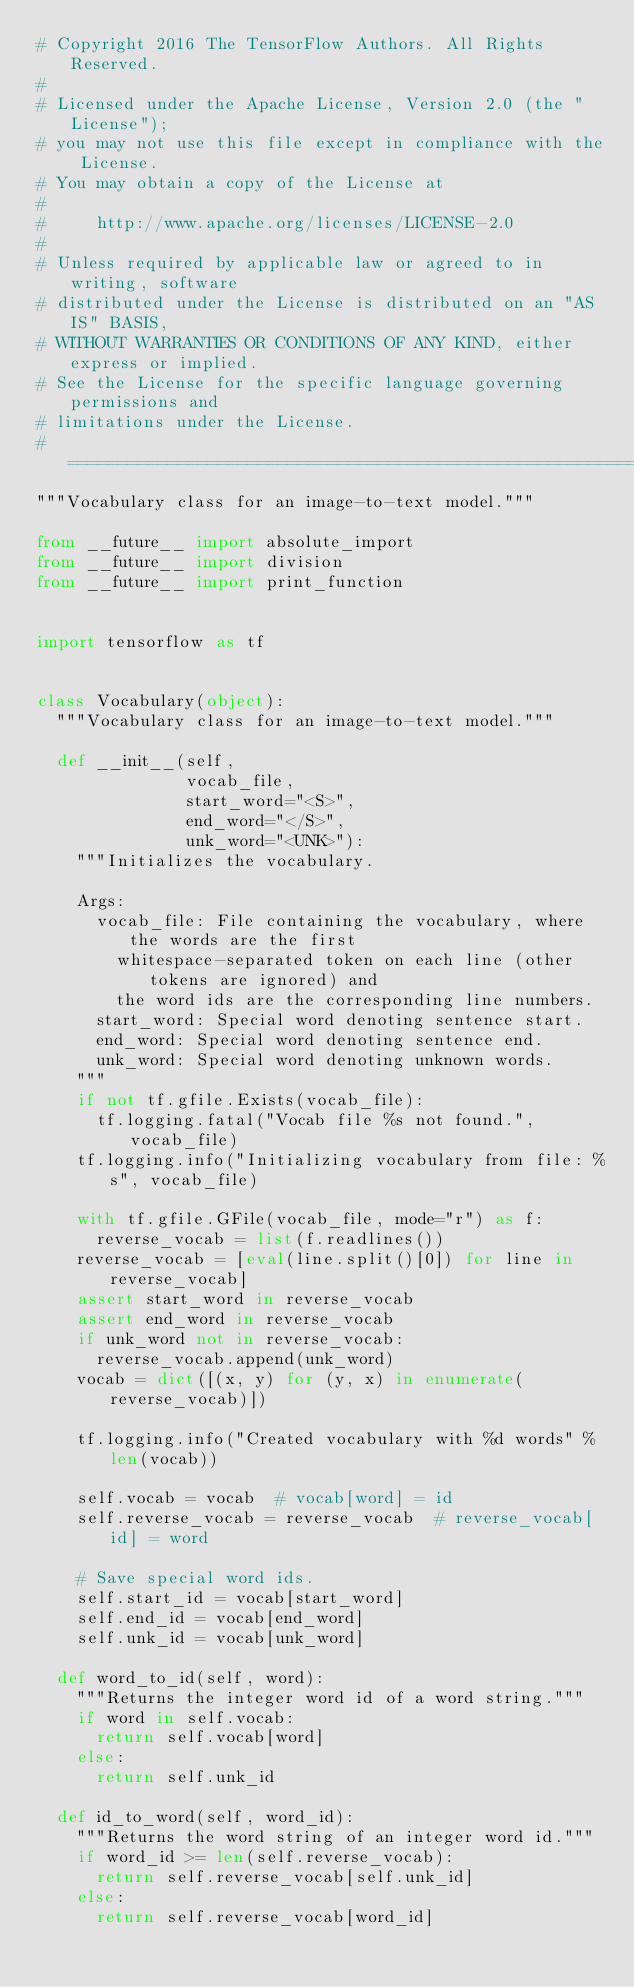<code> <loc_0><loc_0><loc_500><loc_500><_Python_># Copyright 2016 The TensorFlow Authors. All Rights Reserved.
#
# Licensed under the Apache License, Version 2.0 (the "License");
# you may not use this file except in compliance with the License.
# You may obtain a copy of the License at
#
#     http://www.apache.org/licenses/LICENSE-2.0
#
# Unless required by applicable law or agreed to in writing, software
# distributed under the License is distributed on an "AS IS" BASIS,
# WITHOUT WARRANTIES OR CONDITIONS OF ANY KIND, either express or implied.
# See the License for the specific language governing permissions and
# limitations under the License.
# ==============================================================================
"""Vocabulary class for an image-to-text model."""

from __future__ import absolute_import
from __future__ import division
from __future__ import print_function


import tensorflow as tf


class Vocabulary(object):
  """Vocabulary class for an image-to-text model."""

  def __init__(self,
               vocab_file,
               start_word="<S>",
               end_word="</S>",
               unk_word="<UNK>"):
    """Initializes the vocabulary.

    Args:
      vocab_file: File containing the vocabulary, where the words are the first
        whitespace-separated token on each line (other tokens are ignored) and
        the word ids are the corresponding line numbers.
      start_word: Special word denoting sentence start.
      end_word: Special word denoting sentence end.
      unk_word: Special word denoting unknown words.
    """
    if not tf.gfile.Exists(vocab_file):
      tf.logging.fatal("Vocab file %s not found.", vocab_file)
    tf.logging.info("Initializing vocabulary from file: %s", vocab_file)

    with tf.gfile.GFile(vocab_file, mode="r") as f:
      reverse_vocab = list(f.readlines())
    reverse_vocab = [eval(line.split()[0]) for line in reverse_vocab]
    assert start_word in reverse_vocab
    assert end_word in reverse_vocab
    if unk_word not in reverse_vocab:
      reverse_vocab.append(unk_word)
    vocab = dict([(x, y) for (y, x) in enumerate(reverse_vocab)])

    tf.logging.info("Created vocabulary with %d words" % len(vocab))

    self.vocab = vocab  # vocab[word] = id
    self.reverse_vocab = reverse_vocab  # reverse_vocab[id] = word

    # Save special word ids.
    self.start_id = vocab[start_word]
    self.end_id = vocab[end_word]
    self.unk_id = vocab[unk_word]

  def word_to_id(self, word):
    """Returns the integer word id of a word string."""
    if word in self.vocab:
      return self.vocab[word]
    else:
      return self.unk_id

  def id_to_word(self, word_id):
    """Returns the word string of an integer word id."""
    if word_id >= len(self.reverse_vocab):
      return self.reverse_vocab[self.unk_id]
    else:
      return self.reverse_vocab[word_id]
</code> 